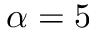<formula> <loc_0><loc_0><loc_500><loc_500>\alpha = 5</formula> 